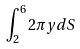<formula> <loc_0><loc_0><loc_500><loc_500>\int _ { 2 } ^ { 6 } 2 \pi y d S</formula> 